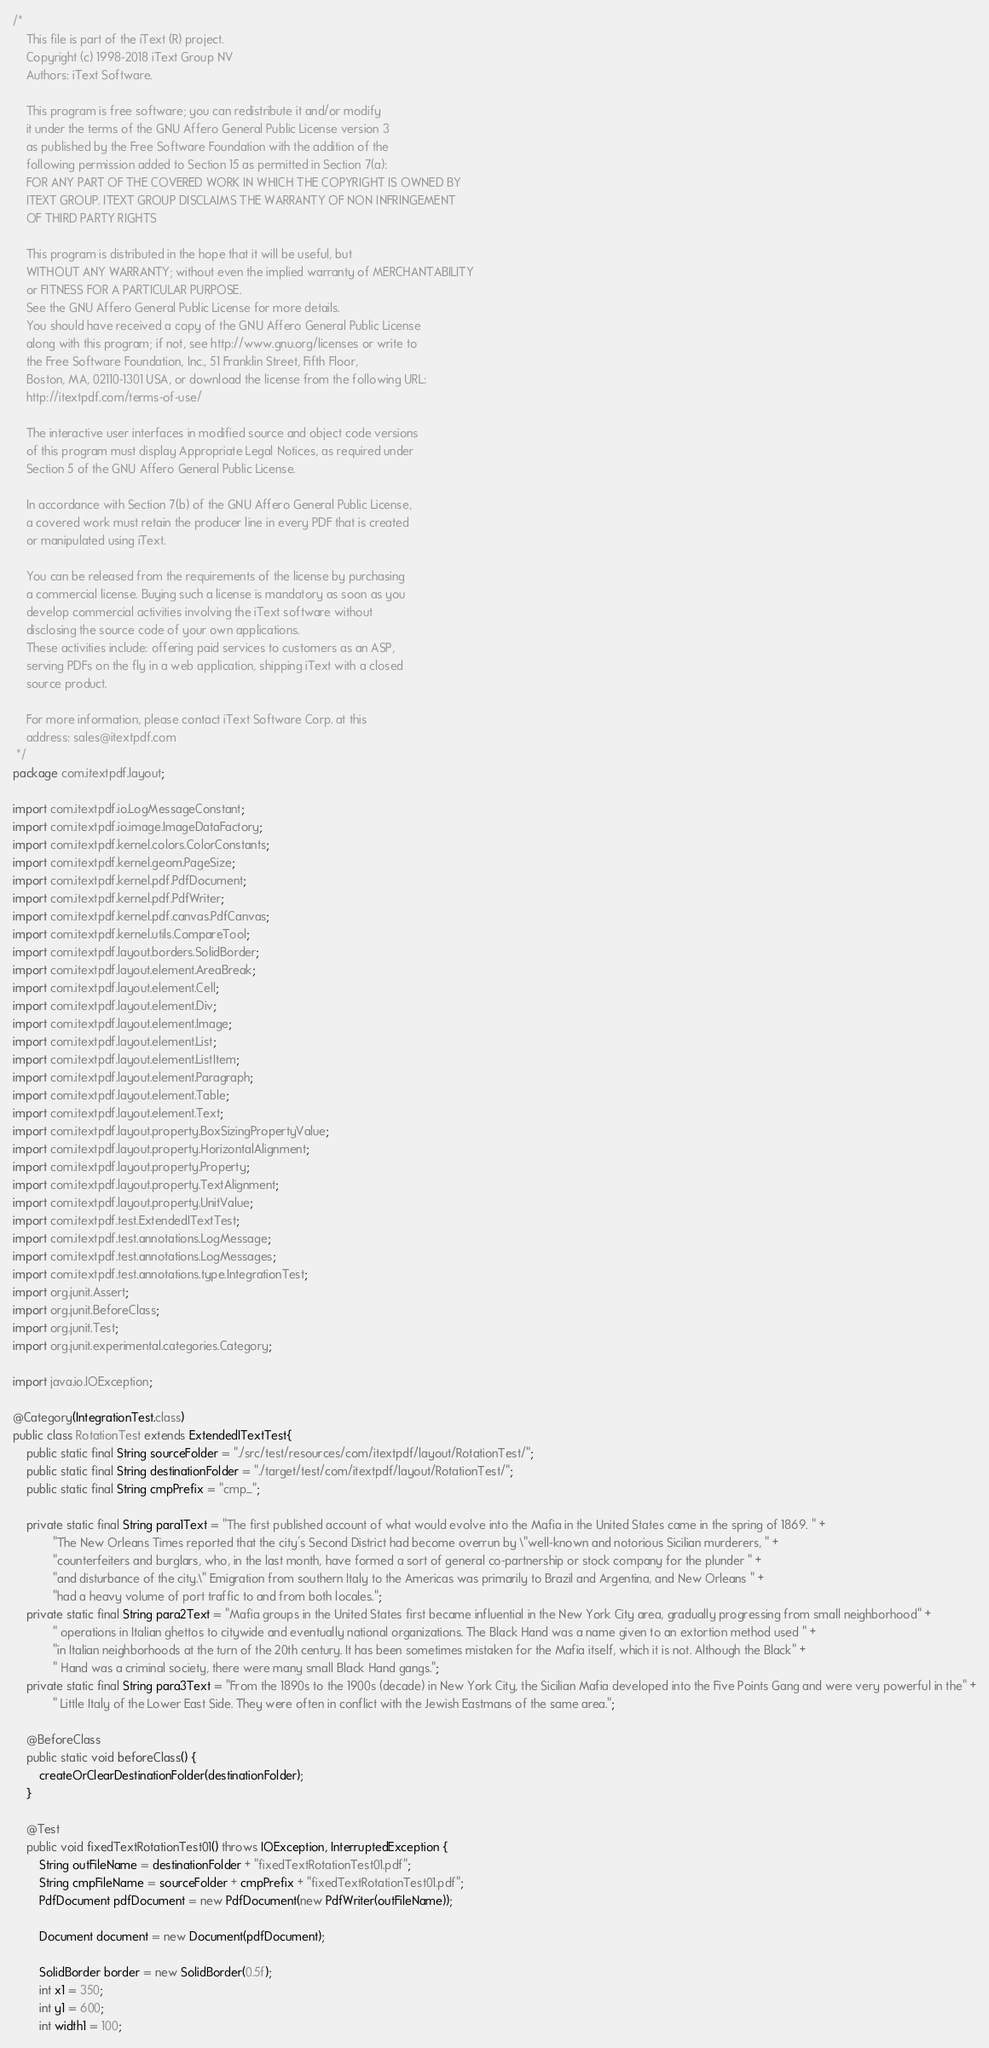Convert code to text. <code><loc_0><loc_0><loc_500><loc_500><_Java_>/*
    This file is part of the iText (R) project.
    Copyright (c) 1998-2018 iText Group NV
    Authors: iText Software.

    This program is free software; you can redistribute it and/or modify
    it under the terms of the GNU Affero General Public License version 3
    as published by the Free Software Foundation with the addition of the
    following permission added to Section 15 as permitted in Section 7(a):
    FOR ANY PART OF THE COVERED WORK IN WHICH THE COPYRIGHT IS OWNED BY
    ITEXT GROUP. ITEXT GROUP DISCLAIMS THE WARRANTY OF NON INFRINGEMENT
    OF THIRD PARTY RIGHTS

    This program is distributed in the hope that it will be useful, but
    WITHOUT ANY WARRANTY; without even the implied warranty of MERCHANTABILITY
    or FITNESS FOR A PARTICULAR PURPOSE.
    See the GNU Affero General Public License for more details.
    You should have received a copy of the GNU Affero General Public License
    along with this program; if not, see http://www.gnu.org/licenses or write to
    the Free Software Foundation, Inc., 51 Franklin Street, Fifth Floor,
    Boston, MA, 02110-1301 USA, or download the license from the following URL:
    http://itextpdf.com/terms-of-use/

    The interactive user interfaces in modified source and object code versions
    of this program must display Appropriate Legal Notices, as required under
    Section 5 of the GNU Affero General Public License.

    In accordance with Section 7(b) of the GNU Affero General Public License,
    a covered work must retain the producer line in every PDF that is created
    or manipulated using iText.

    You can be released from the requirements of the license by purchasing
    a commercial license. Buying such a license is mandatory as soon as you
    develop commercial activities involving the iText software without
    disclosing the source code of your own applications.
    These activities include: offering paid services to customers as an ASP,
    serving PDFs on the fly in a web application, shipping iText with a closed
    source product.

    For more information, please contact iText Software Corp. at this
    address: sales@itextpdf.com
 */
package com.itextpdf.layout;

import com.itextpdf.io.LogMessageConstant;
import com.itextpdf.io.image.ImageDataFactory;
import com.itextpdf.kernel.colors.ColorConstants;
import com.itextpdf.kernel.geom.PageSize;
import com.itextpdf.kernel.pdf.PdfDocument;
import com.itextpdf.kernel.pdf.PdfWriter;
import com.itextpdf.kernel.pdf.canvas.PdfCanvas;
import com.itextpdf.kernel.utils.CompareTool;
import com.itextpdf.layout.borders.SolidBorder;
import com.itextpdf.layout.element.AreaBreak;
import com.itextpdf.layout.element.Cell;
import com.itextpdf.layout.element.Div;
import com.itextpdf.layout.element.Image;
import com.itextpdf.layout.element.List;
import com.itextpdf.layout.element.ListItem;
import com.itextpdf.layout.element.Paragraph;
import com.itextpdf.layout.element.Table;
import com.itextpdf.layout.element.Text;
import com.itextpdf.layout.property.BoxSizingPropertyValue;
import com.itextpdf.layout.property.HorizontalAlignment;
import com.itextpdf.layout.property.Property;
import com.itextpdf.layout.property.TextAlignment;
import com.itextpdf.layout.property.UnitValue;
import com.itextpdf.test.ExtendedITextTest;
import com.itextpdf.test.annotations.LogMessage;
import com.itextpdf.test.annotations.LogMessages;
import com.itextpdf.test.annotations.type.IntegrationTest;
import org.junit.Assert;
import org.junit.BeforeClass;
import org.junit.Test;
import org.junit.experimental.categories.Category;

import java.io.IOException;

@Category(IntegrationTest.class)
public class RotationTest extends ExtendedITextTest{
    public static final String sourceFolder = "./src/test/resources/com/itextpdf/layout/RotationTest/";
    public static final String destinationFolder = "./target/test/com/itextpdf/layout/RotationTest/";
    public static final String cmpPrefix = "cmp_";

    private static final String para1Text = "The first published account of what would evolve into the Mafia in the United States came in the spring of 1869. " +
            "The New Orleans Times reported that the city's Second District had become overrun by \"well-known and notorious Sicilian murderers, " +
            "counterfeiters and burglars, who, in the last month, have formed a sort of general co-partnership or stock company for the plunder " +
            "and disturbance of the city.\" Emigration from southern Italy to the Americas was primarily to Brazil and Argentina, and New Orleans " +
            "had a heavy volume of port traffic to and from both locales.";
    private static final String para2Text = "Mafia groups in the United States first became influential in the New York City area, gradually progressing from small neighborhood" +
            " operations in Italian ghettos to citywide and eventually national organizations. The Black Hand was a name given to an extortion method used " +
            "in Italian neighborhoods at the turn of the 20th century. It has been sometimes mistaken for the Mafia itself, which it is not. Although the Black" +
            " Hand was a criminal society, there were many small Black Hand gangs.";
    private static final String para3Text = "From the 1890s to the 1900s (decade) in New York City, the Sicilian Mafia developed into the Five Points Gang and were very powerful in the" +
            " Little Italy of the Lower East Side. They were often in conflict with the Jewish Eastmans of the same area.";

    @BeforeClass
    public static void beforeClass() {
        createOrClearDestinationFolder(destinationFolder);
    }

    @Test
    public void fixedTextRotationTest01() throws IOException, InterruptedException {
        String outFileName = destinationFolder + "fixedTextRotationTest01.pdf";
        String cmpFileName = sourceFolder + cmpPrefix + "fixedTextRotationTest01.pdf";
        PdfDocument pdfDocument = new PdfDocument(new PdfWriter(outFileName));

        Document document = new Document(pdfDocument);

        SolidBorder border = new SolidBorder(0.5f);
        int x1 = 350;
        int y1 = 600;
        int width1 = 100;</code> 